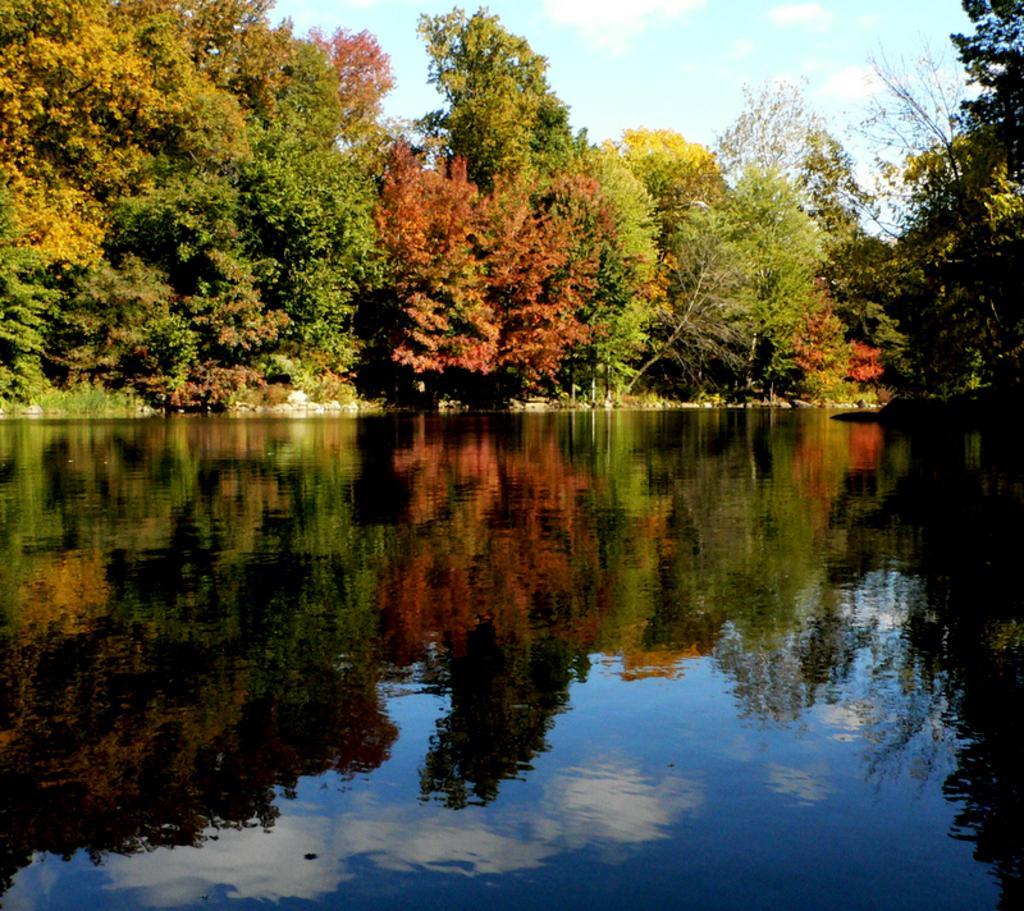Can you describe this image briefly? This picture shows few trees and a blue cloudy sky and we see water. 